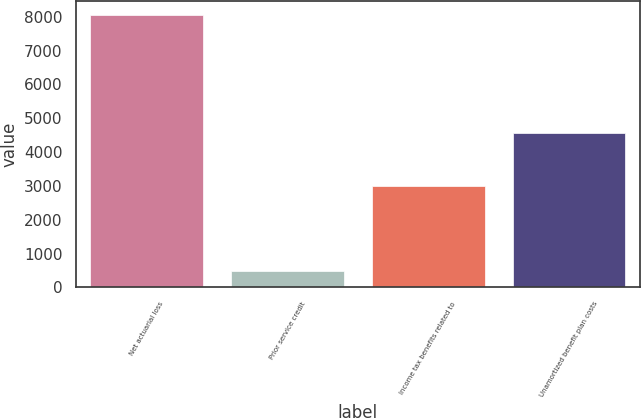Convert chart. <chart><loc_0><loc_0><loc_500><loc_500><bar_chart><fcel>Net actuarial loss<fcel>Prior service credit<fcel>Income tax benefits related to<fcel>Unamortized benefit plan costs<nl><fcel>8057<fcel>481<fcel>3003<fcel>4573<nl></chart> 